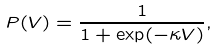Convert formula to latex. <formula><loc_0><loc_0><loc_500><loc_500>P ( V ) = \frac { 1 } { 1 + \exp ( - \kappa V ) } ,</formula> 